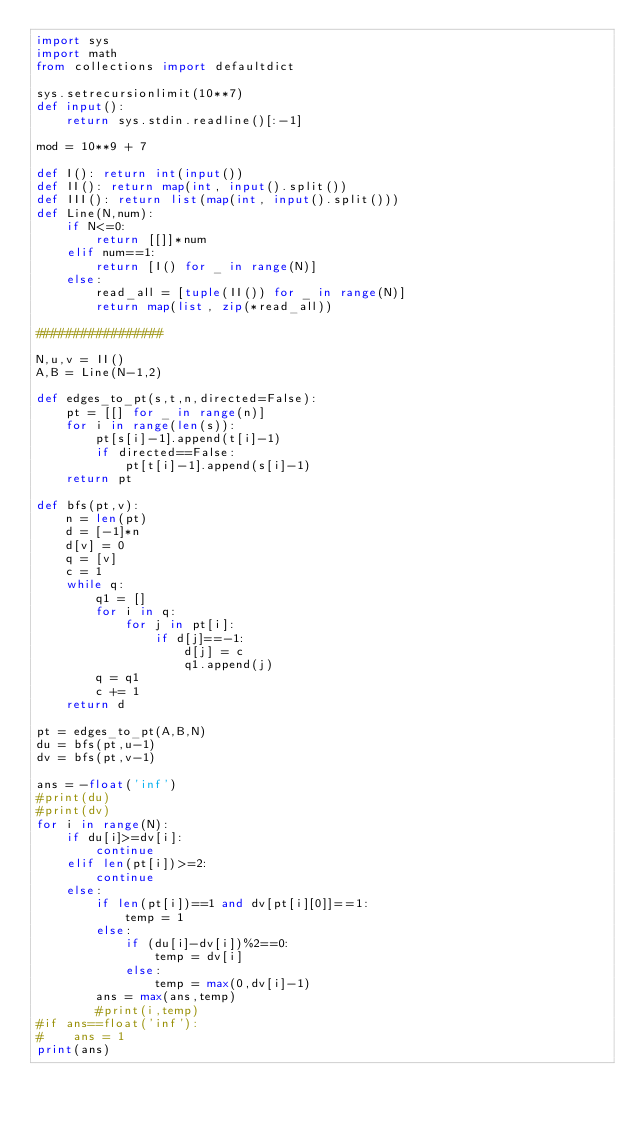<code> <loc_0><loc_0><loc_500><loc_500><_Python_>import sys
import math
from collections import defaultdict

sys.setrecursionlimit(10**7)
def input():
    return sys.stdin.readline()[:-1]

mod = 10**9 + 7

def I(): return int(input())
def II(): return map(int, input().split())
def III(): return list(map(int, input().split()))
def Line(N,num):
    if N<=0:
        return [[]]*num
    elif num==1:
        return [I() for _ in range(N)]
    else:
        read_all = [tuple(II()) for _ in range(N)]
        return map(list, zip(*read_all))

#################

N,u,v = II()
A,B = Line(N-1,2)

def edges_to_pt(s,t,n,directed=False):
    pt = [[] for _ in range(n)]
    for i in range(len(s)):
        pt[s[i]-1].append(t[i]-1)
        if directed==False:
            pt[t[i]-1].append(s[i]-1)
    return pt

def bfs(pt,v):
    n = len(pt)
    d = [-1]*n
    d[v] = 0
    q = [v]
    c = 1
    while q:
        q1 = []
        for i in q:
            for j in pt[i]:
                if d[j]==-1:
                    d[j] = c
                    q1.append(j)
        q = q1
        c += 1
    return d

pt = edges_to_pt(A,B,N)
du = bfs(pt,u-1)
dv = bfs(pt,v-1)

ans = -float('inf')
#print(du)
#print(dv)
for i in range(N):
    if du[i]>=dv[i]:
        continue
    elif len(pt[i])>=2:
        continue
    else:
        if len(pt[i])==1 and dv[pt[i][0]]==1:
            temp = 1
        else:
            if (du[i]-dv[i])%2==0:
                temp = dv[i]
            else:
                temp = max(0,dv[i]-1)
        ans = max(ans,temp)
        #print(i,temp)
#if ans==float('inf'):
#    ans = 1
print(ans)</code> 